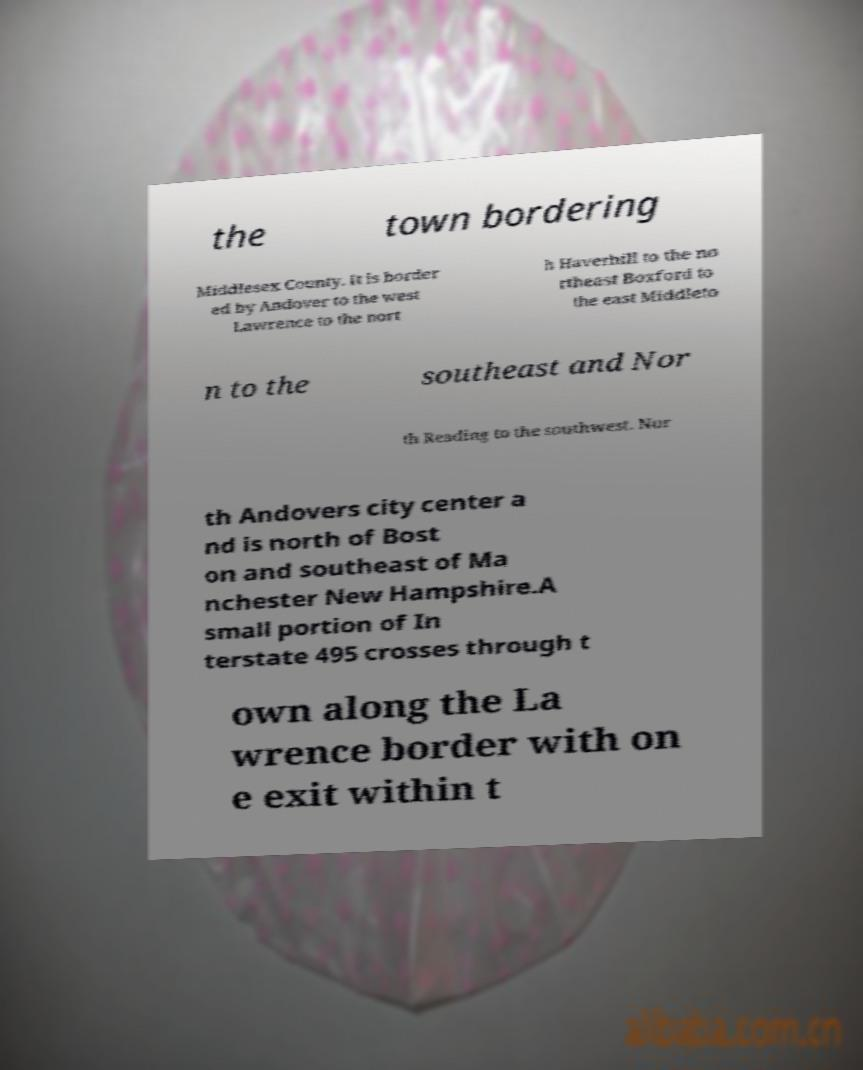I need the written content from this picture converted into text. Can you do that? the town bordering Middlesex County. It is border ed by Andover to the west Lawrence to the nort h Haverhill to the no rtheast Boxford to the east Middleto n to the southeast and Nor th Reading to the southwest. Nor th Andovers city center a nd is north of Bost on and southeast of Ma nchester New Hampshire.A small portion of In terstate 495 crosses through t own along the La wrence border with on e exit within t 